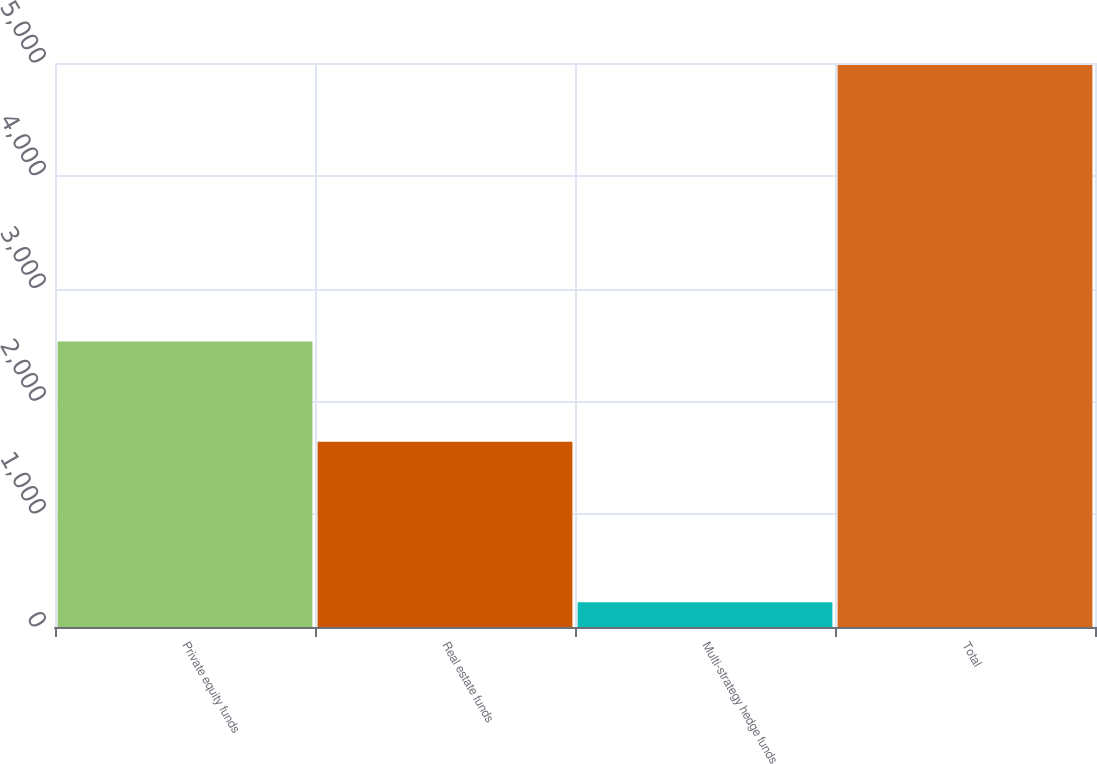Convert chart. <chart><loc_0><loc_0><loc_500><loc_500><bar_chart><fcel>Private equity funds<fcel>Real estate funds<fcel>Multi-strategy hedge funds<fcel>Total<nl><fcel>2531<fcel>1643<fcel>220<fcel>4983<nl></chart> 